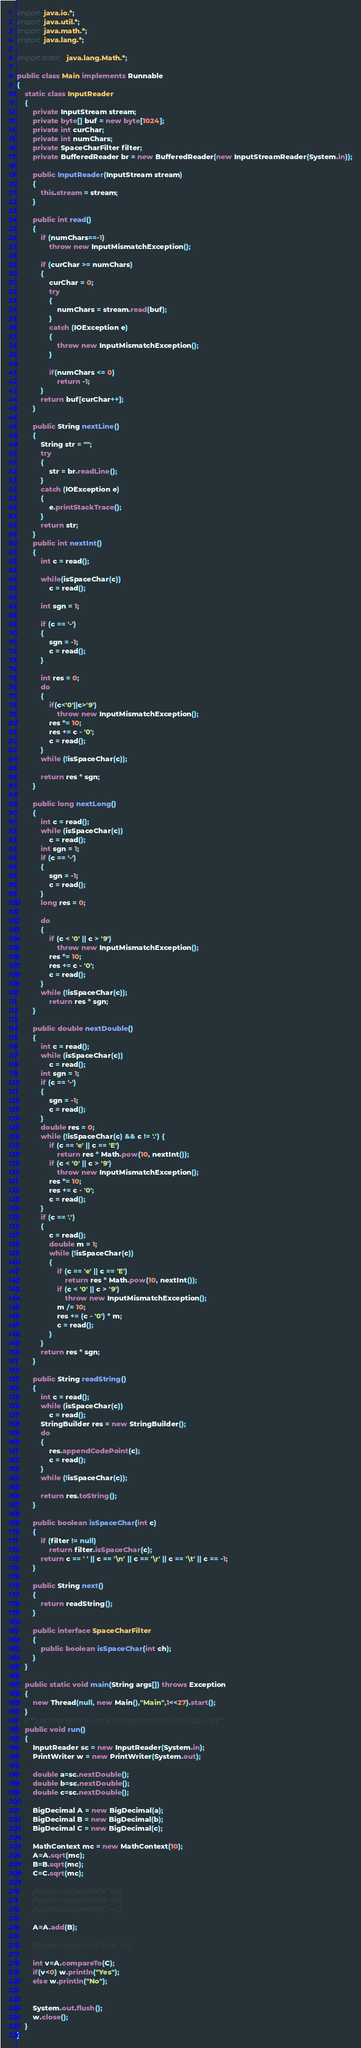Convert code to text. <code><loc_0><loc_0><loc_500><loc_500><_Java_>import java.io.*;
import java.util.*;
import java.math.*;
import java.lang.*;
 
import static java.lang.Math.*;

public class Main implements Runnable 
{
    static class InputReader 
    {
        private InputStream stream;
        private byte[] buf = new byte[1024];
        private int curChar;
        private int numChars;
        private SpaceCharFilter filter;
        private BufferedReader br = new BufferedReader(new InputStreamReader(System.in));

        public InputReader(InputStream stream) 
        {
            this.stream = stream;
        }
        
        public int read()
        {
            if (numChars==-1) 
                throw new InputMismatchException();
            
            if (curChar >= numChars) 
            {
                curChar = 0;
                try
                {
                    numChars = stream.read(buf);
                }
                catch (IOException e)
                {
                    throw new InputMismatchException();
                }
                
                if(numChars <= 0)               
                    return -1;
            }
            return buf[curChar++];
        }
     
        public String nextLine()
        {
            String str = "";
            try
            {
                str = br.readLine();
            }
            catch (IOException e)
            {
                e.printStackTrace();
            }
            return str;
        }
        public int nextInt() 
        {
            int c = read();
            
            while(isSpaceChar(c)) 
                c = read();
            
            int sgn = 1;
        
            if (c == '-') 
            {
                sgn = -1;
                c = read();
            }
            
            int res = 0;
            do
            {
                if(c<'0'||c>'9') 
                    throw new InputMismatchException();
                res *= 10;
                res += c - '0';
                c = read();
            }
            while (!isSpaceChar(c)); 
        
            return res * sgn;
        }
        
        public long nextLong() 
        {
            int c = read();
            while (isSpaceChar(c))
                c = read();
            int sgn = 1;
            if (c == '-')
            {
                sgn = -1;
                c = read();
            }
            long res = 0;
            
            do 
            {
                if (c < '0' || c > '9')
                    throw new InputMismatchException();
                res *= 10;
                res += c - '0';
                c = read();
            }
            while (!isSpaceChar(c));
                return res * sgn;
        }
        
        public double nextDouble() 
        {
            int c = read();
            while (isSpaceChar(c))
                c = read();
            int sgn = 1;
            if (c == '-')
            {
                sgn = -1;
                c = read();
            }
            double res = 0;
            while (!isSpaceChar(c) && c != '.') {
                if (c == 'e' || c == 'E')
                    return res * Math.pow(10, nextInt());
                if (c < '0' || c > '9')
                    throw new InputMismatchException();
                res *= 10;
                res += c - '0';
                c = read();
            }
            if (c == '.') 
            {
                c = read();
                double m = 1;
                while (!isSpaceChar(c))
                {
                    if (c == 'e' || c == 'E')
                        return res * Math.pow(10, nextInt());
                    if (c < '0' || c > '9')
                        throw new InputMismatchException();
                    m /= 10;
                    res += (c - '0') * m;
                    c = read();
                }
            }
            return res * sgn;
        }
    
        public String readString() 
        {
            int c = read();
            while (isSpaceChar(c))
                c = read();
            StringBuilder res = new StringBuilder();
            do 
            {
                res.appendCodePoint(c);
                c = read();
            } 
            while (!isSpaceChar(c));
            
            return res.toString();
        }
     
        public boolean isSpaceChar(int c) 
        {
            if (filter != null)
                return filter.isSpaceChar(c);
            return c == ' ' || c == '\n' || c == '\r' || c == '\t' || c == -1;
        }
     
        public String next()
        {
            return readString();
        }
        
        public interface SpaceCharFilter
        {
            public boolean isSpaceChar(int ch);
        }
    }
	
    public static void main(String args[]) throws Exception 
    {
        new Thread(null, new Main(),"Main",1<<27).start();
    }
	// **just change the name of class from Main to reuquired**
    public void run()
    {
        InputReader sc = new InputReader(System.in);
        PrintWriter w = new PrintWriter(System.out);
		
		double a=sc.nextDouble();
		double b=sc.nextDouble();
		double c=sc.nextDouble();
		
		BigDecimal A = new BigDecimal(a);
		BigDecimal B = new BigDecimal(b);
		BigDecimal C = new BigDecimal(c);
		
		MathContext mc = new MathContext(10);
		A=A.sqrt(mc);
		B=B.sqrt(mc);
		C=C.sqrt(mc);
		
		//System.out.println("A:"+A);
		//System.out.println("B:"+B);
		//System.out.println("C:"+C);
		
		A=A.add(B);
		
		//System.out.println("sum:"+A);
		
		int v=A.compareTo(C);
		if(v<0) w.println("Yes");
		else w.println("No");
		
		
        System.out.flush();
        w.close();
    }
}</code> 